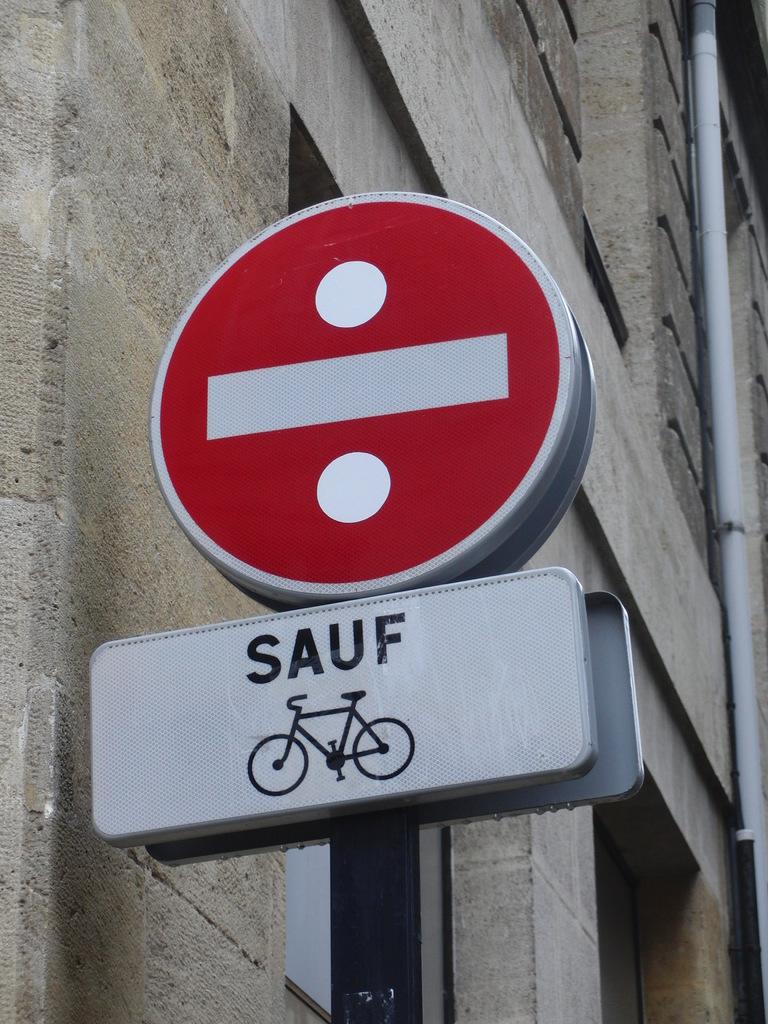What word is above the bike?
Provide a short and direct response. Sauf. 